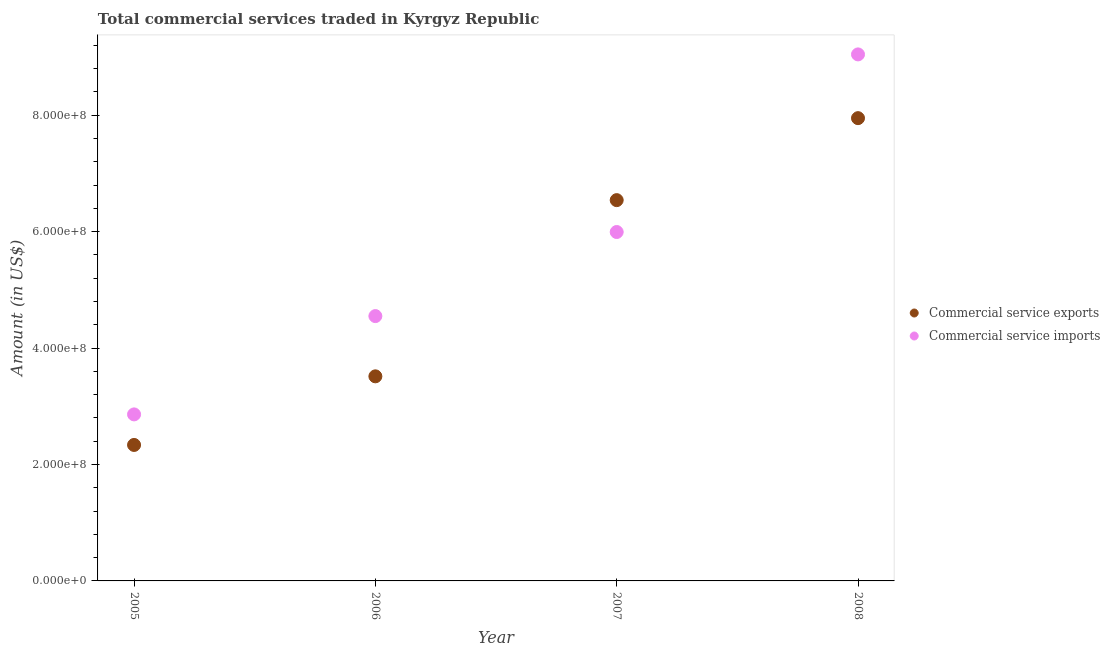How many different coloured dotlines are there?
Your answer should be compact. 2. What is the amount of commercial service exports in 2006?
Your response must be concise. 3.51e+08. Across all years, what is the maximum amount of commercial service exports?
Provide a short and direct response. 7.95e+08. Across all years, what is the minimum amount of commercial service imports?
Your answer should be compact. 2.86e+08. In which year was the amount of commercial service imports maximum?
Offer a very short reply. 2008. In which year was the amount of commercial service imports minimum?
Your response must be concise. 2005. What is the total amount of commercial service imports in the graph?
Your answer should be very brief. 2.24e+09. What is the difference between the amount of commercial service exports in 2007 and that in 2008?
Your answer should be compact. -1.41e+08. What is the difference between the amount of commercial service exports in 2005 and the amount of commercial service imports in 2008?
Keep it short and to the point. -6.71e+08. What is the average amount of commercial service exports per year?
Keep it short and to the point. 5.08e+08. In the year 2006, what is the difference between the amount of commercial service imports and amount of commercial service exports?
Keep it short and to the point. 1.03e+08. In how many years, is the amount of commercial service exports greater than 400000000 US$?
Keep it short and to the point. 2. What is the ratio of the amount of commercial service imports in 2006 to that in 2007?
Offer a terse response. 0.76. Is the difference between the amount of commercial service exports in 2006 and 2007 greater than the difference between the amount of commercial service imports in 2006 and 2007?
Provide a short and direct response. No. What is the difference between the highest and the second highest amount of commercial service exports?
Keep it short and to the point. 1.41e+08. What is the difference between the highest and the lowest amount of commercial service exports?
Offer a terse response. 5.61e+08. Is the sum of the amount of commercial service imports in 2006 and 2008 greater than the maximum amount of commercial service exports across all years?
Offer a terse response. Yes. Is the amount of commercial service imports strictly greater than the amount of commercial service exports over the years?
Ensure brevity in your answer.  No. What is the difference between two consecutive major ticks on the Y-axis?
Offer a terse response. 2.00e+08. Does the graph contain any zero values?
Keep it short and to the point. No. Where does the legend appear in the graph?
Provide a short and direct response. Center right. How many legend labels are there?
Make the answer very short. 2. How are the legend labels stacked?
Ensure brevity in your answer.  Vertical. What is the title of the graph?
Your answer should be very brief. Total commercial services traded in Kyrgyz Republic. What is the label or title of the X-axis?
Provide a short and direct response. Year. What is the label or title of the Y-axis?
Provide a short and direct response. Amount (in US$). What is the Amount (in US$) of Commercial service exports in 2005?
Provide a short and direct response. 2.34e+08. What is the Amount (in US$) in Commercial service imports in 2005?
Provide a short and direct response. 2.86e+08. What is the Amount (in US$) of Commercial service exports in 2006?
Provide a short and direct response. 3.51e+08. What is the Amount (in US$) of Commercial service imports in 2006?
Ensure brevity in your answer.  4.55e+08. What is the Amount (in US$) in Commercial service exports in 2007?
Keep it short and to the point. 6.54e+08. What is the Amount (in US$) of Commercial service imports in 2007?
Your answer should be very brief. 5.99e+08. What is the Amount (in US$) of Commercial service exports in 2008?
Give a very brief answer. 7.95e+08. What is the Amount (in US$) in Commercial service imports in 2008?
Provide a succinct answer. 9.04e+08. Across all years, what is the maximum Amount (in US$) of Commercial service exports?
Your answer should be very brief. 7.95e+08. Across all years, what is the maximum Amount (in US$) of Commercial service imports?
Give a very brief answer. 9.04e+08. Across all years, what is the minimum Amount (in US$) of Commercial service exports?
Your response must be concise. 2.34e+08. Across all years, what is the minimum Amount (in US$) of Commercial service imports?
Provide a succinct answer. 2.86e+08. What is the total Amount (in US$) of Commercial service exports in the graph?
Your answer should be compact. 2.03e+09. What is the total Amount (in US$) of Commercial service imports in the graph?
Provide a short and direct response. 2.24e+09. What is the difference between the Amount (in US$) of Commercial service exports in 2005 and that in 2006?
Offer a terse response. -1.18e+08. What is the difference between the Amount (in US$) of Commercial service imports in 2005 and that in 2006?
Offer a terse response. -1.69e+08. What is the difference between the Amount (in US$) of Commercial service exports in 2005 and that in 2007?
Offer a very short reply. -4.21e+08. What is the difference between the Amount (in US$) in Commercial service imports in 2005 and that in 2007?
Offer a terse response. -3.13e+08. What is the difference between the Amount (in US$) of Commercial service exports in 2005 and that in 2008?
Provide a short and direct response. -5.61e+08. What is the difference between the Amount (in US$) of Commercial service imports in 2005 and that in 2008?
Ensure brevity in your answer.  -6.18e+08. What is the difference between the Amount (in US$) of Commercial service exports in 2006 and that in 2007?
Give a very brief answer. -3.03e+08. What is the difference between the Amount (in US$) of Commercial service imports in 2006 and that in 2007?
Provide a short and direct response. -1.44e+08. What is the difference between the Amount (in US$) of Commercial service exports in 2006 and that in 2008?
Your answer should be compact. -4.43e+08. What is the difference between the Amount (in US$) in Commercial service imports in 2006 and that in 2008?
Offer a very short reply. -4.49e+08. What is the difference between the Amount (in US$) of Commercial service exports in 2007 and that in 2008?
Your answer should be very brief. -1.41e+08. What is the difference between the Amount (in US$) in Commercial service imports in 2007 and that in 2008?
Your answer should be very brief. -3.05e+08. What is the difference between the Amount (in US$) in Commercial service exports in 2005 and the Amount (in US$) in Commercial service imports in 2006?
Make the answer very short. -2.21e+08. What is the difference between the Amount (in US$) of Commercial service exports in 2005 and the Amount (in US$) of Commercial service imports in 2007?
Your response must be concise. -3.66e+08. What is the difference between the Amount (in US$) in Commercial service exports in 2005 and the Amount (in US$) in Commercial service imports in 2008?
Keep it short and to the point. -6.71e+08. What is the difference between the Amount (in US$) in Commercial service exports in 2006 and the Amount (in US$) in Commercial service imports in 2007?
Ensure brevity in your answer.  -2.48e+08. What is the difference between the Amount (in US$) of Commercial service exports in 2006 and the Amount (in US$) of Commercial service imports in 2008?
Make the answer very short. -5.53e+08. What is the difference between the Amount (in US$) of Commercial service exports in 2007 and the Amount (in US$) of Commercial service imports in 2008?
Keep it short and to the point. -2.50e+08. What is the average Amount (in US$) of Commercial service exports per year?
Your response must be concise. 5.08e+08. What is the average Amount (in US$) in Commercial service imports per year?
Your response must be concise. 5.61e+08. In the year 2005, what is the difference between the Amount (in US$) of Commercial service exports and Amount (in US$) of Commercial service imports?
Offer a terse response. -5.25e+07. In the year 2006, what is the difference between the Amount (in US$) of Commercial service exports and Amount (in US$) of Commercial service imports?
Give a very brief answer. -1.03e+08. In the year 2007, what is the difference between the Amount (in US$) of Commercial service exports and Amount (in US$) of Commercial service imports?
Provide a succinct answer. 5.48e+07. In the year 2008, what is the difference between the Amount (in US$) of Commercial service exports and Amount (in US$) of Commercial service imports?
Your answer should be compact. -1.09e+08. What is the ratio of the Amount (in US$) of Commercial service exports in 2005 to that in 2006?
Keep it short and to the point. 0.66. What is the ratio of the Amount (in US$) of Commercial service imports in 2005 to that in 2006?
Keep it short and to the point. 0.63. What is the ratio of the Amount (in US$) of Commercial service exports in 2005 to that in 2007?
Provide a succinct answer. 0.36. What is the ratio of the Amount (in US$) of Commercial service imports in 2005 to that in 2007?
Your response must be concise. 0.48. What is the ratio of the Amount (in US$) in Commercial service exports in 2005 to that in 2008?
Ensure brevity in your answer.  0.29. What is the ratio of the Amount (in US$) in Commercial service imports in 2005 to that in 2008?
Keep it short and to the point. 0.32. What is the ratio of the Amount (in US$) in Commercial service exports in 2006 to that in 2007?
Offer a terse response. 0.54. What is the ratio of the Amount (in US$) in Commercial service imports in 2006 to that in 2007?
Provide a succinct answer. 0.76. What is the ratio of the Amount (in US$) of Commercial service exports in 2006 to that in 2008?
Keep it short and to the point. 0.44. What is the ratio of the Amount (in US$) in Commercial service imports in 2006 to that in 2008?
Ensure brevity in your answer.  0.5. What is the ratio of the Amount (in US$) in Commercial service exports in 2007 to that in 2008?
Your answer should be compact. 0.82. What is the ratio of the Amount (in US$) in Commercial service imports in 2007 to that in 2008?
Provide a short and direct response. 0.66. What is the difference between the highest and the second highest Amount (in US$) in Commercial service exports?
Offer a terse response. 1.41e+08. What is the difference between the highest and the second highest Amount (in US$) of Commercial service imports?
Keep it short and to the point. 3.05e+08. What is the difference between the highest and the lowest Amount (in US$) of Commercial service exports?
Give a very brief answer. 5.61e+08. What is the difference between the highest and the lowest Amount (in US$) in Commercial service imports?
Your response must be concise. 6.18e+08. 